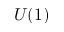Convert formula to latex. <formula><loc_0><loc_0><loc_500><loc_500>U ( 1 )</formula> 